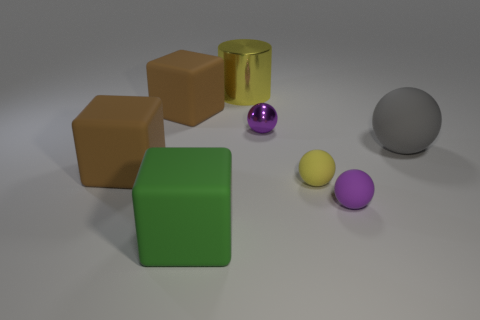Are there fewer green objects than brown objects?
Offer a very short reply. Yes. There is a gray thing that is the same shape as the small purple shiny thing; what size is it?
Your answer should be compact. Large. Does the yellow object in front of the big cylinder have the same material as the green thing?
Offer a very short reply. Yes. Is the small yellow matte object the same shape as the big yellow shiny object?
Ensure brevity in your answer.  No. How many things are either large objects on the left side of the cylinder or small brown matte cylinders?
Offer a terse response. 3. There is a ball that is the same material as the big yellow thing; what size is it?
Provide a short and direct response. Small. What number of big matte blocks have the same color as the big rubber sphere?
Keep it short and to the point. 0. How many big things are green rubber spheres or purple rubber objects?
Offer a terse response. 0. There is a rubber object that is the same color as the big cylinder; what is its size?
Your response must be concise. Small. Are there any gray objects that have the same material as the yellow cylinder?
Provide a short and direct response. No. 